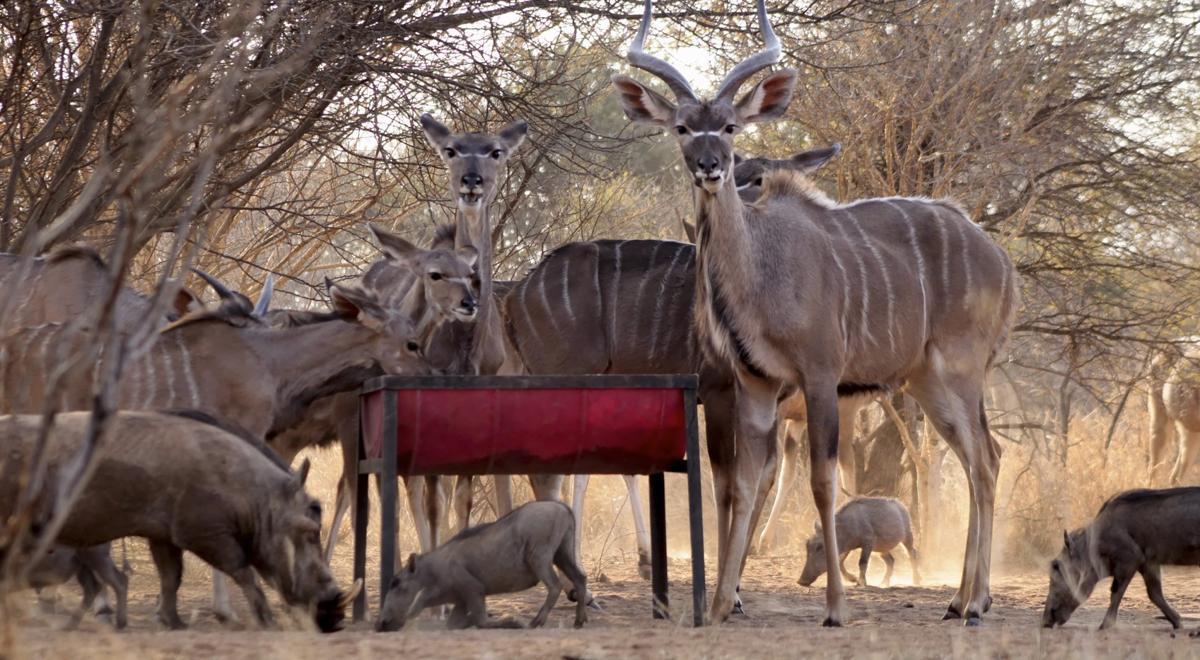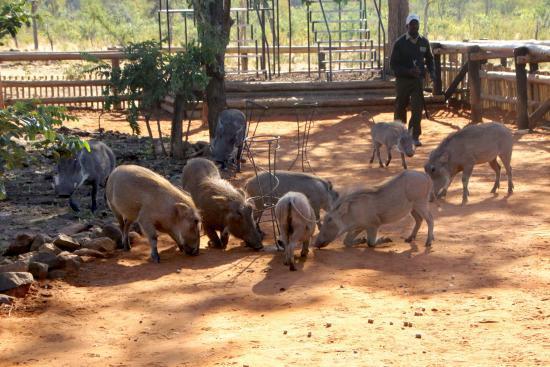The first image is the image on the left, the second image is the image on the right. Given the left and right images, does the statement "There is at least one person in one of the pictures." hold true? Answer yes or no. Yes. 